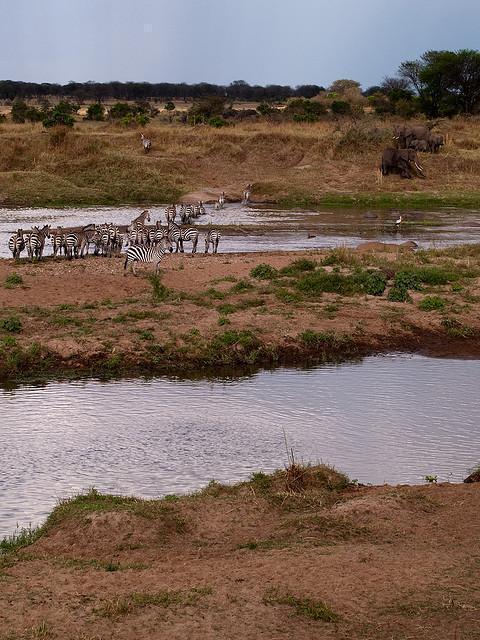How many birds are standing inside of the river with the zebras on the island?
Choose the right answer from the provided options to respond to the question.
Options: Three, four, two, one. One. 